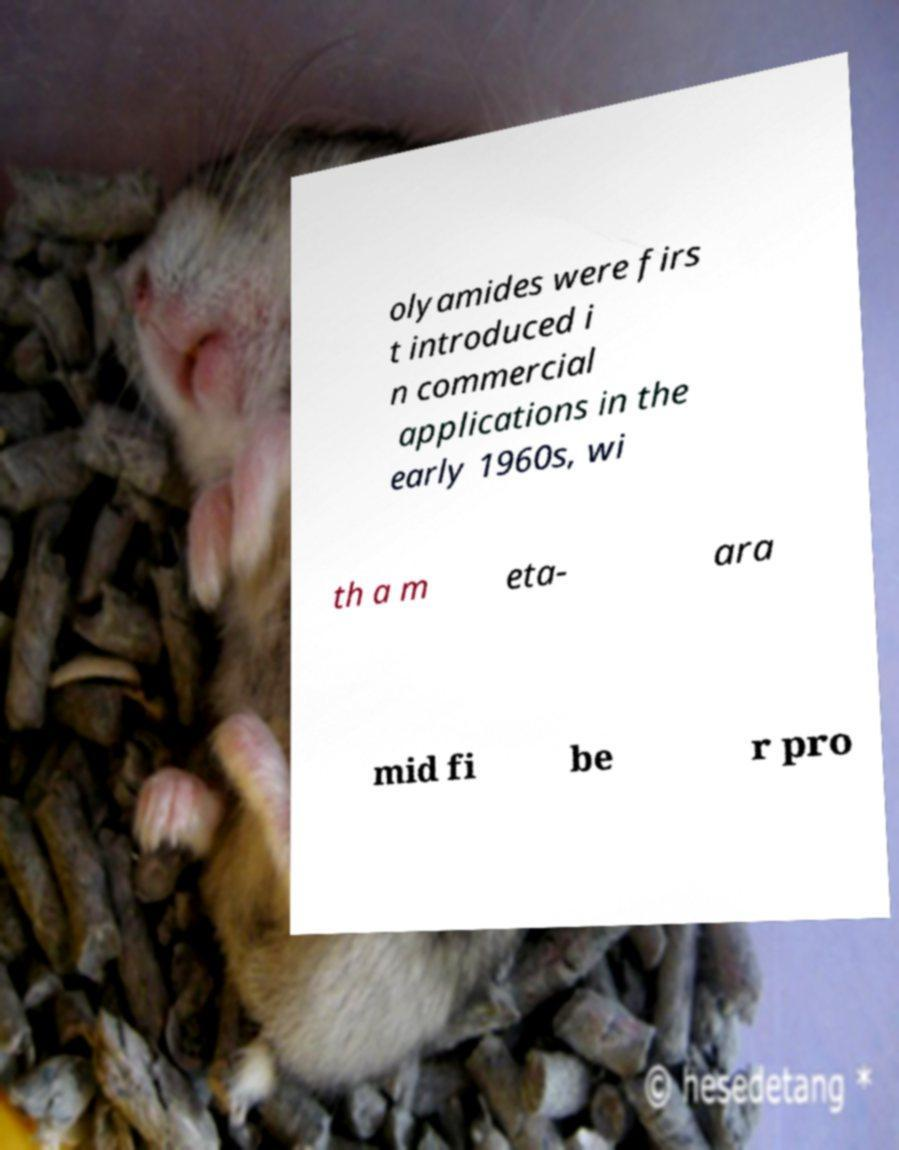Please read and relay the text visible in this image. What does it say? olyamides were firs t introduced i n commercial applications in the early 1960s, wi th a m eta- ara mid fi be r pro 